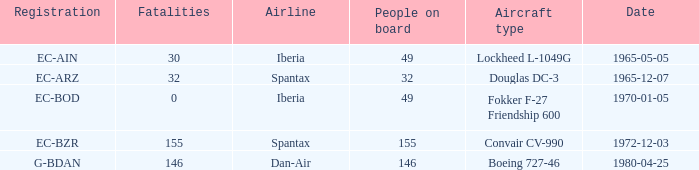How many fatalities are there for the airline of spantax, with a registration of ec-arz? 32.0. 